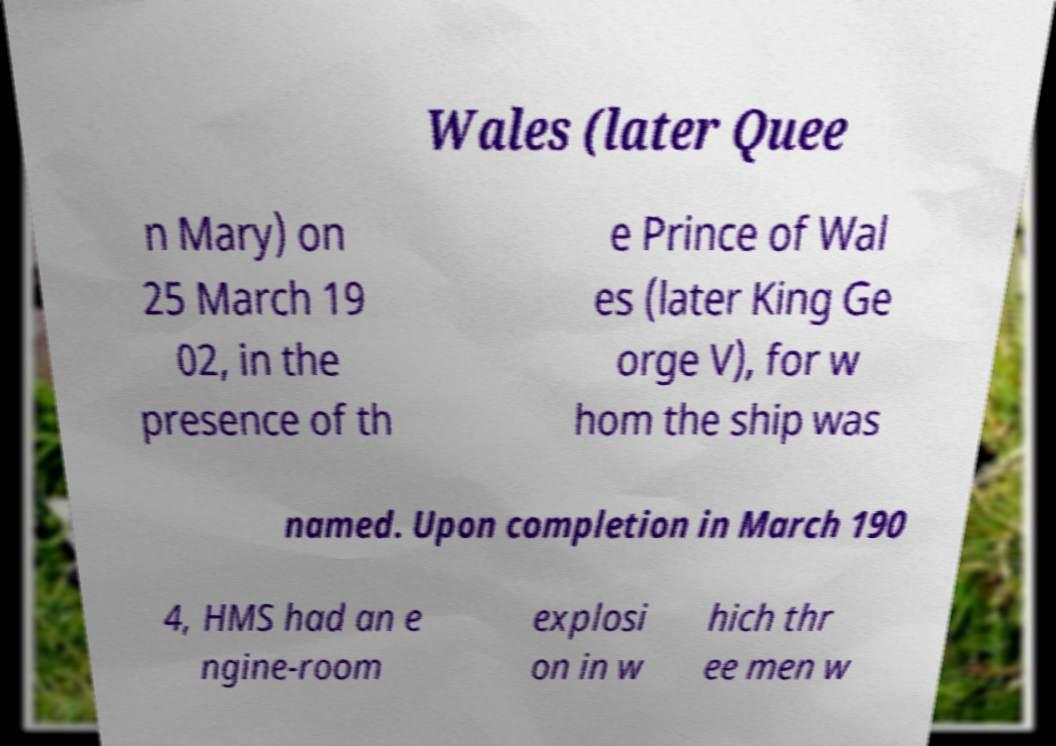There's text embedded in this image that I need extracted. Can you transcribe it verbatim? Wales (later Quee n Mary) on 25 March 19 02, in the presence of th e Prince of Wal es (later King Ge orge V), for w hom the ship was named. Upon completion in March 190 4, HMS had an e ngine-room explosi on in w hich thr ee men w 